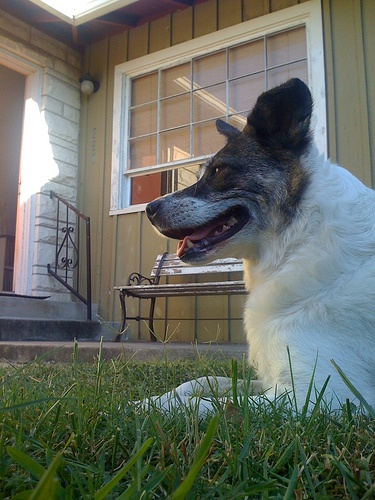Describe the objects in this image and their specific colors. I can see dog in gray, darkgray, and black tones and bench in gray, black, and darkgray tones in this image. 